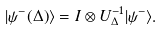<formula> <loc_0><loc_0><loc_500><loc_500>| \psi ^ { - } ( \Delta ) \rangle = I \otimes U _ { \Delta } ^ { - 1 } | \psi ^ { - } \rangle .</formula> 